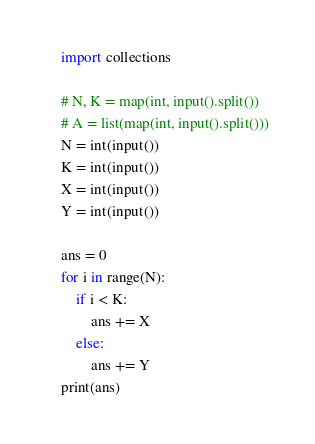<code> <loc_0><loc_0><loc_500><loc_500><_Python_>    import collections

    # N, K = map(int, input().split())
    # A = list(map(int, input().split()))
    N = int(input())
    K = int(input())
    X = int(input())
    Y = int(input())

    ans = 0
    for i in range(N):
        if i < K:
            ans += X
        else:
            ans += Y
    print(ans)</code> 